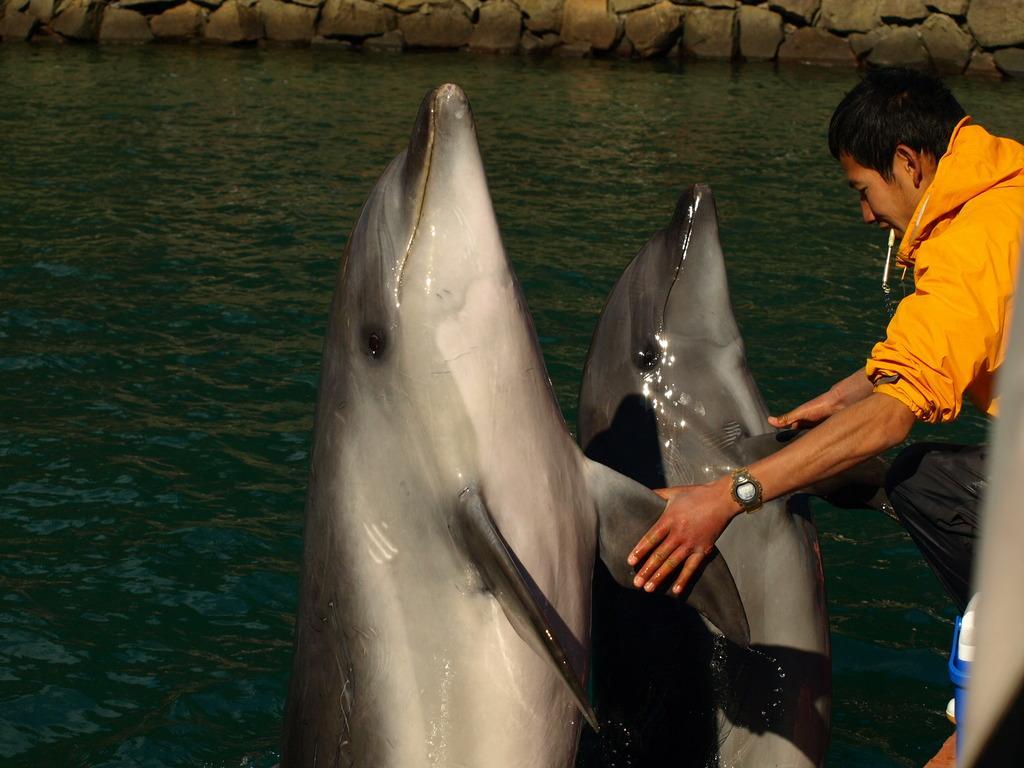Please provide a concise description of this image. In the image we can see there is a person who is holding dolphins and there is a water over here. 